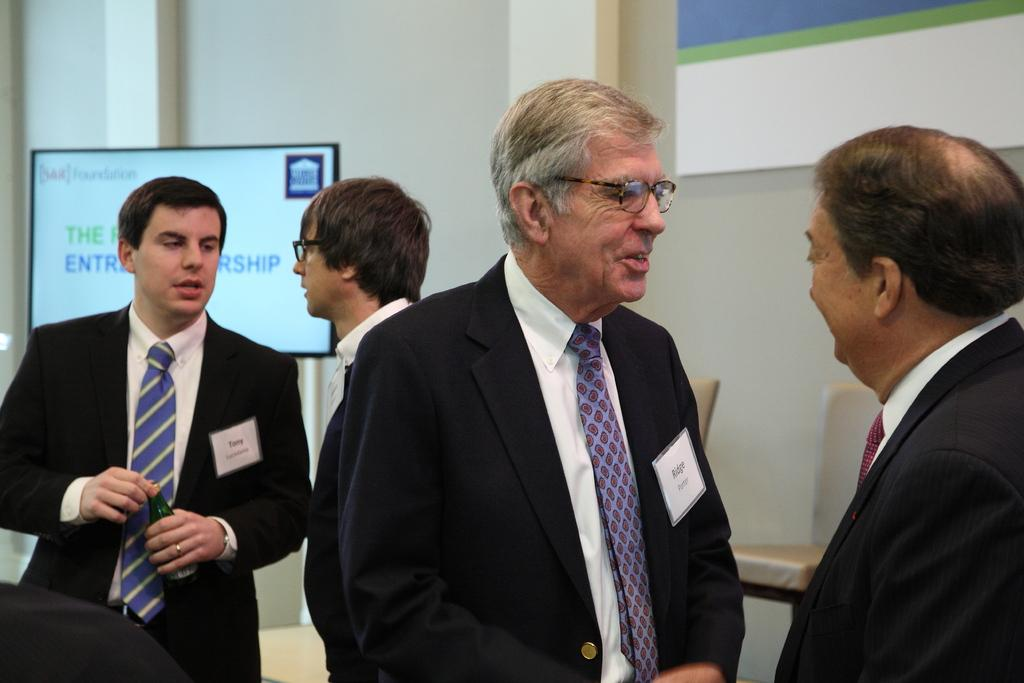How many people are present in the image? There are four people in the image. Where are the people located? The people are standing in a room. What are the people wearing? The people are wearing suits. What are the people doing in the image? The people are talking to each other. What can be seen on the wall in the room? There is a screen in the room. What furniture is present in the room? There are chairs in the room. Can you tell me how many bees are buzzing around the people in the image? There are no bees present in the image. 